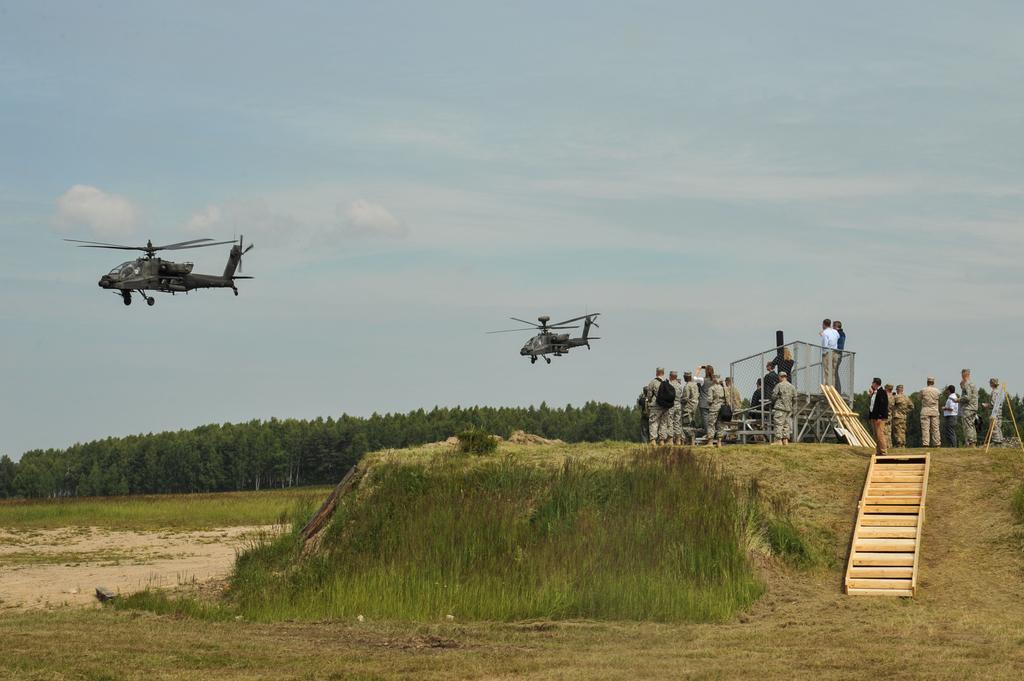Could you give a brief overview of what you see in this image? In this image we can see helicopters flying in the air. Here we can see ground, grass, trees, people, steps, and few objects. In the background there is sky with clouds. 